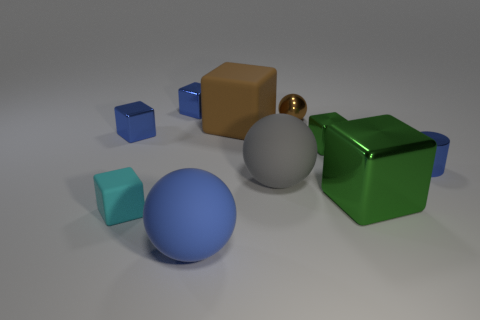Is there a brown thing that has the same size as the blue rubber object?
Offer a terse response. Yes. What is the object in front of the cyan matte cube made of?
Ensure brevity in your answer.  Rubber. Does the ball that is in front of the cyan object have the same material as the big gray thing?
Keep it short and to the point. Yes. There is a brown matte thing that is the same size as the blue rubber thing; what is its shape?
Keep it short and to the point. Cube. What number of tiny metallic things have the same color as the tiny sphere?
Your answer should be very brief. 0. Is the number of big green things on the left side of the small matte block less than the number of big matte objects that are behind the big brown cube?
Your answer should be very brief. No. Are there any large blue rubber objects to the left of the tiny cyan matte object?
Give a very brief answer. No. There is a large sphere that is on the right side of the matte block that is right of the blue sphere; is there a large matte ball that is in front of it?
Your answer should be very brief. Yes. Does the metal object to the left of the cyan matte block have the same shape as the large brown thing?
Offer a very short reply. Yes. There is a tiny ball that is the same material as the cylinder; what color is it?
Offer a terse response. Brown. 